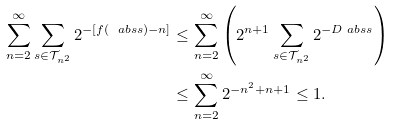<formula> <loc_0><loc_0><loc_500><loc_500>\sum _ { n = 2 } ^ { \infty } \sum _ { s \in \mathcal { T } _ { n ^ { 2 } } } 2 ^ { - [ f ( \ a b s { s } ) - n ] } & \leq \sum _ { n = 2 } ^ { \infty } \left ( 2 ^ { n + 1 } \sum _ { s \in \mathcal { T } _ { n ^ { 2 } } } 2 ^ { - D \ a b s { s } } \right ) \\ & \leq \sum _ { n = 2 } ^ { \infty } 2 ^ { - n ^ { 2 } + n + 1 } \leq 1 .</formula> 